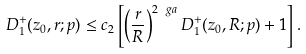<formula> <loc_0><loc_0><loc_500><loc_500>D ^ { + } _ { 1 } ( z _ { 0 } , r ; p ) \leq c _ { 2 } \left [ \left ( \frac { r } { R } \right ) ^ { 2 \ g a } D ^ { + } _ { 1 } ( z _ { 0 } , R ; p ) + 1 \right ] .</formula> 